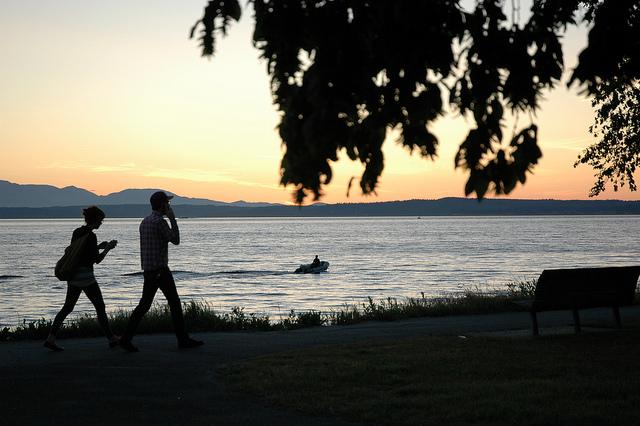How many boats r in the water?
Concise answer only. 1. How many boats are in the water?
Concise answer only. 1. What can be seen over the water?
Write a very short answer. Boat. What are the people holding?
Short answer required. Phones. What is the person carrying?
Short answer required. Phone. What is the guy holding?
Keep it brief. Phone. What does the weather look like?
Keep it brief. Clear. What time of day is it?
Write a very short answer. Sunset. Where is the boat?
Concise answer only. Water. Do you see a beach?
Quick response, please. No. Are both of these people adults?
Short answer required. Yes. Is the man watching the boat?
Write a very short answer. No. Is it raining?
Concise answer only. No. What is on the ground by their feet?
Answer briefly. Grass. What made the dark spots in the foreground?
Keep it brief. People. What kind of body of water is in the image?
Give a very brief answer. Lake. Are two of the people wading?
Short answer required. No. Have the people finished surfing?
Give a very brief answer. Yes. Are there any trees?
Concise answer only. Yes. 